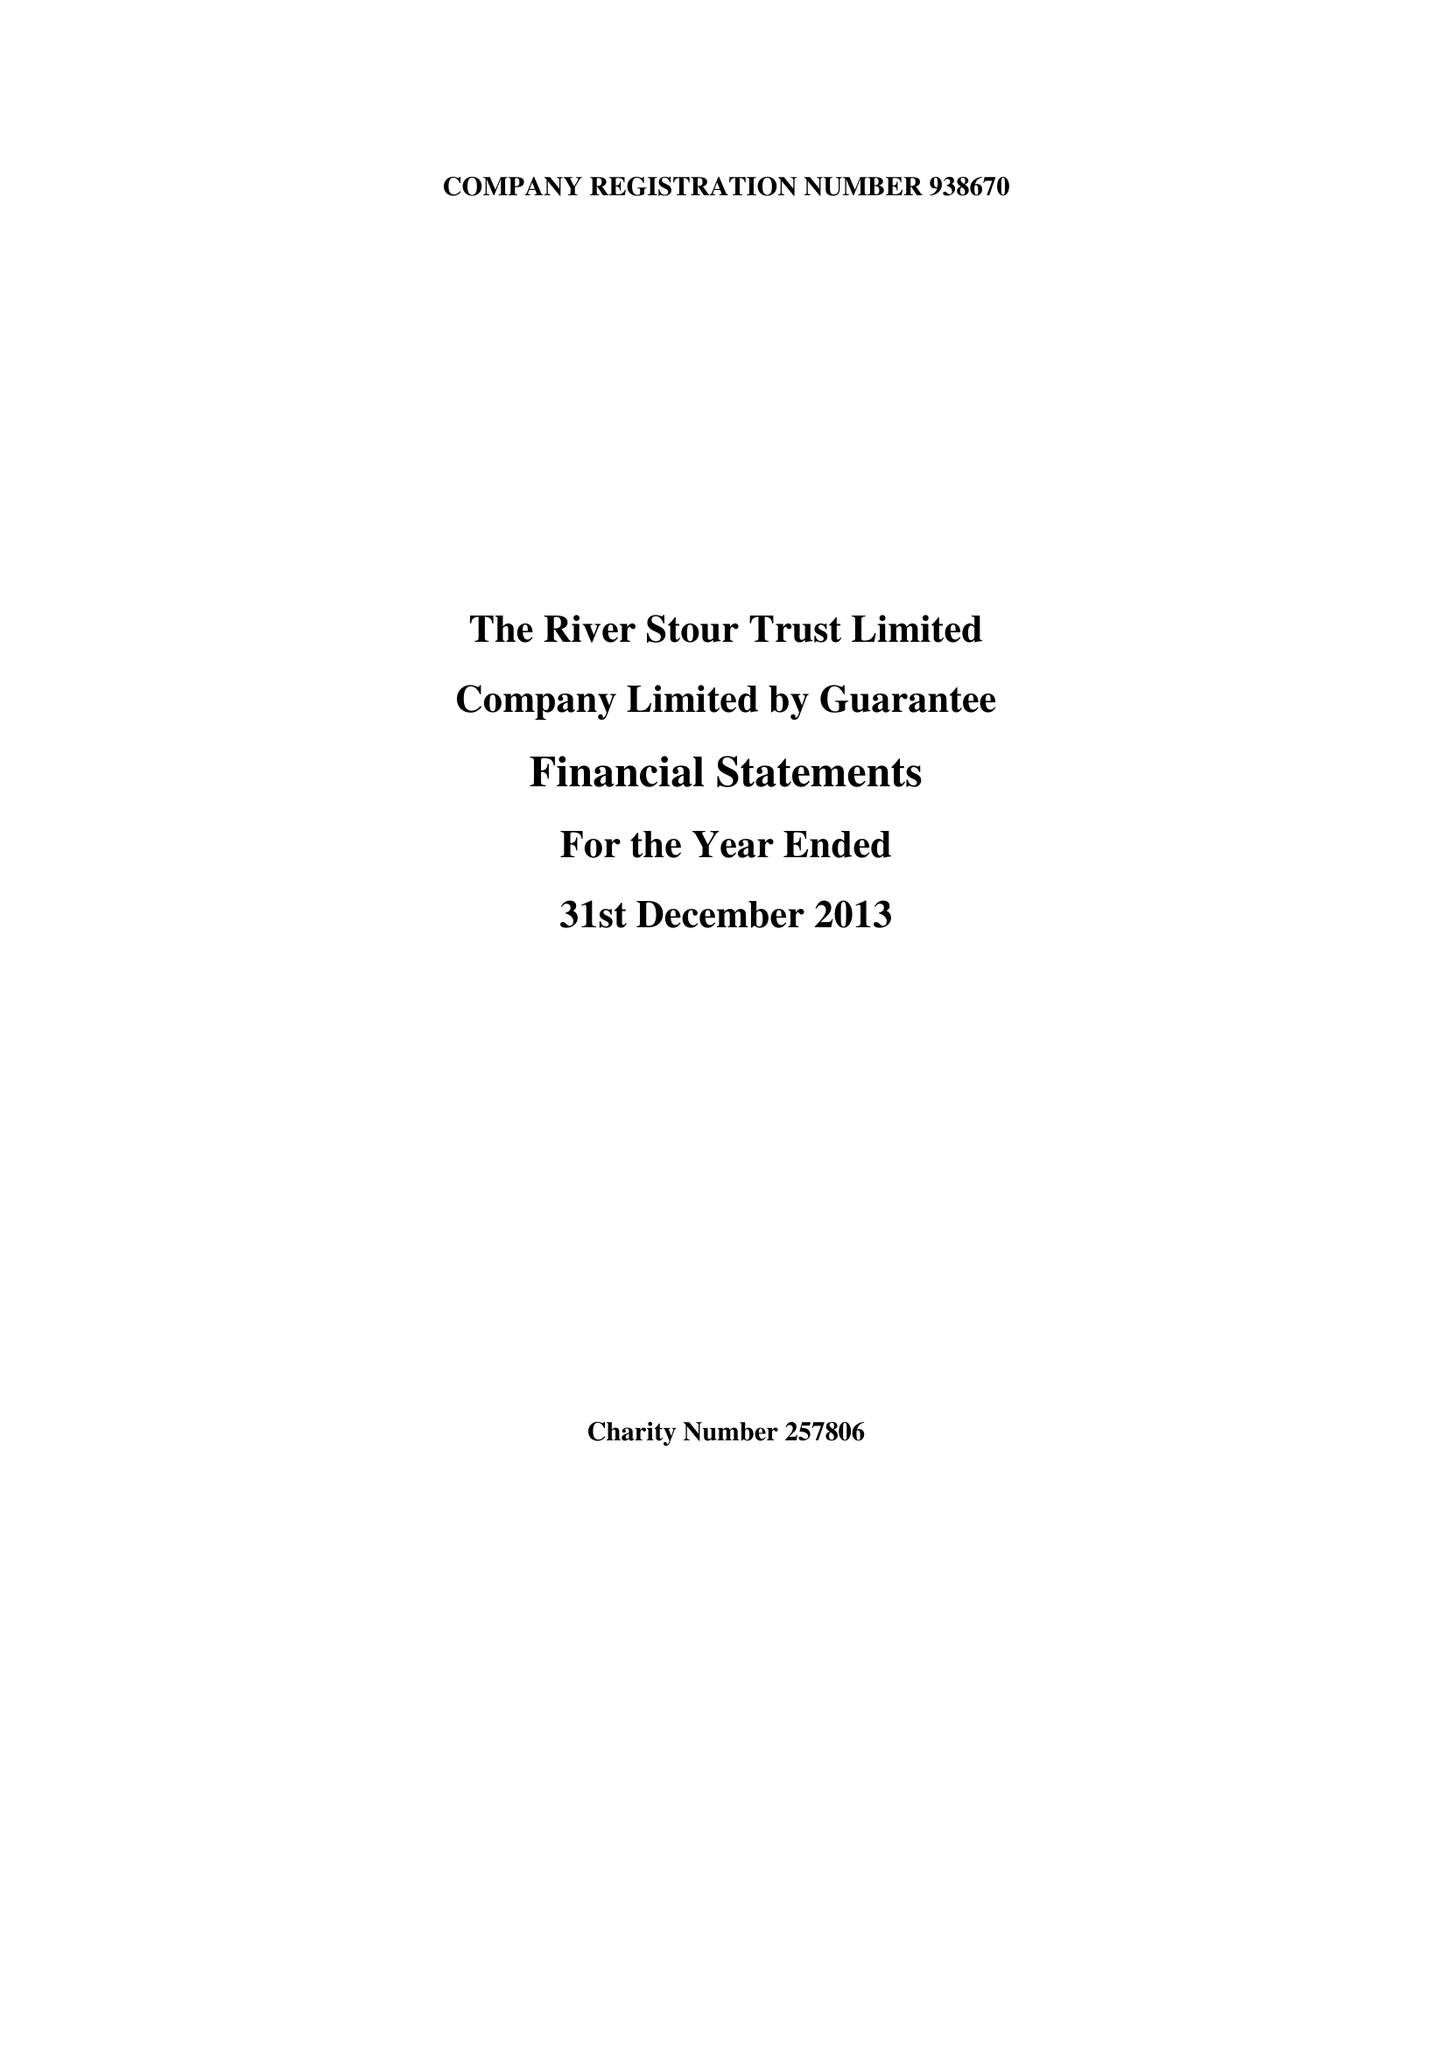What is the value for the address__postcode?
Answer the question using a single word or phrase. CO10 2AN 